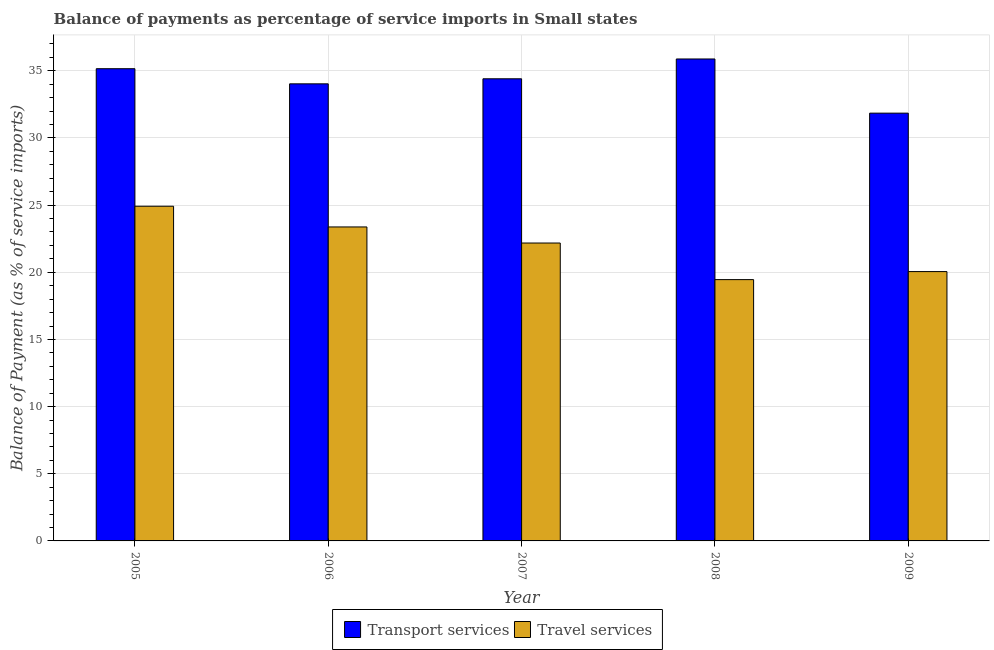How many different coloured bars are there?
Offer a terse response. 2. Are the number of bars per tick equal to the number of legend labels?
Make the answer very short. Yes. Are the number of bars on each tick of the X-axis equal?
Provide a short and direct response. Yes. What is the label of the 1st group of bars from the left?
Provide a succinct answer. 2005. In how many cases, is the number of bars for a given year not equal to the number of legend labels?
Provide a short and direct response. 0. What is the balance of payments of transport services in 2006?
Provide a succinct answer. 34.03. Across all years, what is the maximum balance of payments of transport services?
Make the answer very short. 35.88. Across all years, what is the minimum balance of payments of travel services?
Provide a succinct answer. 19.45. In which year was the balance of payments of transport services minimum?
Ensure brevity in your answer.  2009. What is the total balance of payments of travel services in the graph?
Your answer should be compact. 109.98. What is the difference between the balance of payments of travel services in 2007 and that in 2009?
Provide a succinct answer. 2.13. What is the difference between the balance of payments of transport services in 2008 and the balance of payments of travel services in 2009?
Provide a short and direct response. 4.03. What is the average balance of payments of transport services per year?
Your answer should be very brief. 34.26. What is the ratio of the balance of payments of travel services in 2005 to that in 2009?
Make the answer very short. 1.24. Is the balance of payments of travel services in 2006 less than that in 2007?
Offer a very short reply. No. Is the difference between the balance of payments of travel services in 2006 and 2007 greater than the difference between the balance of payments of transport services in 2006 and 2007?
Provide a succinct answer. No. What is the difference between the highest and the second highest balance of payments of travel services?
Keep it short and to the point. 1.54. What is the difference between the highest and the lowest balance of payments of transport services?
Offer a very short reply. 4.03. In how many years, is the balance of payments of travel services greater than the average balance of payments of travel services taken over all years?
Offer a very short reply. 3. Is the sum of the balance of payments of travel services in 2006 and 2009 greater than the maximum balance of payments of transport services across all years?
Provide a short and direct response. Yes. What does the 2nd bar from the left in 2005 represents?
Your response must be concise. Travel services. What does the 1st bar from the right in 2006 represents?
Offer a very short reply. Travel services. How many bars are there?
Your response must be concise. 10. How many years are there in the graph?
Provide a succinct answer. 5. Does the graph contain any zero values?
Give a very brief answer. No. How many legend labels are there?
Ensure brevity in your answer.  2. What is the title of the graph?
Ensure brevity in your answer.  Balance of payments as percentage of service imports in Small states. What is the label or title of the X-axis?
Your answer should be compact. Year. What is the label or title of the Y-axis?
Provide a short and direct response. Balance of Payment (as % of service imports). What is the Balance of Payment (as % of service imports) in Transport services in 2005?
Make the answer very short. 35.16. What is the Balance of Payment (as % of service imports) of Travel services in 2005?
Provide a succinct answer. 24.92. What is the Balance of Payment (as % of service imports) in Transport services in 2006?
Your answer should be very brief. 34.03. What is the Balance of Payment (as % of service imports) of Travel services in 2006?
Your response must be concise. 23.38. What is the Balance of Payment (as % of service imports) in Transport services in 2007?
Your answer should be compact. 34.41. What is the Balance of Payment (as % of service imports) in Travel services in 2007?
Provide a short and direct response. 22.18. What is the Balance of Payment (as % of service imports) of Transport services in 2008?
Offer a terse response. 35.88. What is the Balance of Payment (as % of service imports) in Travel services in 2008?
Provide a succinct answer. 19.45. What is the Balance of Payment (as % of service imports) of Transport services in 2009?
Your answer should be compact. 31.85. What is the Balance of Payment (as % of service imports) of Travel services in 2009?
Give a very brief answer. 20.05. Across all years, what is the maximum Balance of Payment (as % of service imports) in Transport services?
Offer a terse response. 35.88. Across all years, what is the maximum Balance of Payment (as % of service imports) in Travel services?
Provide a short and direct response. 24.92. Across all years, what is the minimum Balance of Payment (as % of service imports) of Transport services?
Make the answer very short. 31.85. Across all years, what is the minimum Balance of Payment (as % of service imports) in Travel services?
Give a very brief answer. 19.45. What is the total Balance of Payment (as % of service imports) of Transport services in the graph?
Give a very brief answer. 171.32. What is the total Balance of Payment (as % of service imports) in Travel services in the graph?
Your answer should be compact. 109.98. What is the difference between the Balance of Payment (as % of service imports) in Transport services in 2005 and that in 2006?
Offer a terse response. 1.13. What is the difference between the Balance of Payment (as % of service imports) of Travel services in 2005 and that in 2006?
Provide a short and direct response. 1.54. What is the difference between the Balance of Payment (as % of service imports) of Transport services in 2005 and that in 2007?
Your answer should be compact. 0.75. What is the difference between the Balance of Payment (as % of service imports) in Travel services in 2005 and that in 2007?
Your response must be concise. 2.74. What is the difference between the Balance of Payment (as % of service imports) of Transport services in 2005 and that in 2008?
Offer a terse response. -0.72. What is the difference between the Balance of Payment (as % of service imports) in Travel services in 2005 and that in 2008?
Make the answer very short. 5.46. What is the difference between the Balance of Payment (as % of service imports) of Transport services in 2005 and that in 2009?
Offer a very short reply. 3.31. What is the difference between the Balance of Payment (as % of service imports) of Travel services in 2005 and that in 2009?
Your answer should be very brief. 4.87. What is the difference between the Balance of Payment (as % of service imports) in Transport services in 2006 and that in 2007?
Your answer should be very brief. -0.38. What is the difference between the Balance of Payment (as % of service imports) of Travel services in 2006 and that in 2007?
Make the answer very short. 1.2. What is the difference between the Balance of Payment (as % of service imports) of Transport services in 2006 and that in 2008?
Your answer should be very brief. -1.85. What is the difference between the Balance of Payment (as % of service imports) of Travel services in 2006 and that in 2008?
Provide a succinct answer. 3.92. What is the difference between the Balance of Payment (as % of service imports) of Transport services in 2006 and that in 2009?
Provide a short and direct response. 2.18. What is the difference between the Balance of Payment (as % of service imports) of Travel services in 2006 and that in 2009?
Give a very brief answer. 3.32. What is the difference between the Balance of Payment (as % of service imports) in Transport services in 2007 and that in 2008?
Ensure brevity in your answer.  -1.48. What is the difference between the Balance of Payment (as % of service imports) of Travel services in 2007 and that in 2008?
Your answer should be very brief. 2.72. What is the difference between the Balance of Payment (as % of service imports) of Transport services in 2007 and that in 2009?
Make the answer very short. 2.56. What is the difference between the Balance of Payment (as % of service imports) in Travel services in 2007 and that in 2009?
Your answer should be compact. 2.13. What is the difference between the Balance of Payment (as % of service imports) in Transport services in 2008 and that in 2009?
Your answer should be very brief. 4.03. What is the difference between the Balance of Payment (as % of service imports) in Travel services in 2008 and that in 2009?
Your response must be concise. -0.6. What is the difference between the Balance of Payment (as % of service imports) of Transport services in 2005 and the Balance of Payment (as % of service imports) of Travel services in 2006?
Offer a terse response. 11.78. What is the difference between the Balance of Payment (as % of service imports) in Transport services in 2005 and the Balance of Payment (as % of service imports) in Travel services in 2007?
Provide a short and direct response. 12.98. What is the difference between the Balance of Payment (as % of service imports) of Transport services in 2005 and the Balance of Payment (as % of service imports) of Travel services in 2008?
Make the answer very short. 15.7. What is the difference between the Balance of Payment (as % of service imports) of Transport services in 2005 and the Balance of Payment (as % of service imports) of Travel services in 2009?
Give a very brief answer. 15.1. What is the difference between the Balance of Payment (as % of service imports) in Transport services in 2006 and the Balance of Payment (as % of service imports) in Travel services in 2007?
Provide a short and direct response. 11.85. What is the difference between the Balance of Payment (as % of service imports) in Transport services in 2006 and the Balance of Payment (as % of service imports) in Travel services in 2008?
Offer a very short reply. 14.58. What is the difference between the Balance of Payment (as % of service imports) of Transport services in 2006 and the Balance of Payment (as % of service imports) of Travel services in 2009?
Your response must be concise. 13.98. What is the difference between the Balance of Payment (as % of service imports) of Transport services in 2007 and the Balance of Payment (as % of service imports) of Travel services in 2008?
Offer a terse response. 14.95. What is the difference between the Balance of Payment (as % of service imports) of Transport services in 2007 and the Balance of Payment (as % of service imports) of Travel services in 2009?
Your response must be concise. 14.35. What is the difference between the Balance of Payment (as % of service imports) in Transport services in 2008 and the Balance of Payment (as % of service imports) in Travel services in 2009?
Provide a succinct answer. 15.83. What is the average Balance of Payment (as % of service imports) of Transport services per year?
Keep it short and to the point. 34.26. What is the average Balance of Payment (as % of service imports) in Travel services per year?
Your answer should be compact. 22. In the year 2005, what is the difference between the Balance of Payment (as % of service imports) in Transport services and Balance of Payment (as % of service imports) in Travel services?
Your answer should be compact. 10.24. In the year 2006, what is the difference between the Balance of Payment (as % of service imports) of Transport services and Balance of Payment (as % of service imports) of Travel services?
Provide a short and direct response. 10.65. In the year 2007, what is the difference between the Balance of Payment (as % of service imports) in Transport services and Balance of Payment (as % of service imports) in Travel services?
Make the answer very short. 12.23. In the year 2008, what is the difference between the Balance of Payment (as % of service imports) of Transport services and Balance of Payment (as % of service imports) of Travel services?
Offer a terse response. 16.43. In the year 2009, what is the difference between the Balance of Payment (as % of service imports) in Transport services and Balance of Payment (as % of service imports) in Travel services?
Make the answer very short. 11.8. What is the ratio of the Balance of Payment (as % of service imports) in Transport services in 2005 to that in 2006?
Make the answer very short. 1.03. What is the ratio of the Balance of Payment (as % of service imports) in Travel services in 2005 to that in 2006?
Make the answer very short. 1.07. What is the ratio of the Balance of Payment (as % of service imports) in Transport services in 2005 to that in 2007?
Provide a short and direct response. 1.02. What is the ratio of the Balance of Payment (as % of service imports) of Travel services in 2005 to that in 2007?
Give a very brief answer. 1.12. What is the ratio of the Balance of Payment (as % of service imports) in Transport services in 2005 to that in 2008?
Your answer should be very brief. 0.98. What is the ratio of the Balance of Payment (as % of service imports) of Travel services in 2005 to that in 2008?
Keep it short and to the point. 1.28. What is the ratio of the Balance of Payment (as % of service imports) in Transport services in 2005 to that in 2009?
Your answer should be very brief. 1.1. What is the ratio of the Balance of Payment (as % of service imports) in Travel services in 2005 to that in 2009?
Provide a succinct answer. 1.24. What is the ratio of the Balance of Payment (as % of service imports) in Travel services in 2006 to that in 2007?
Your answer should be compact. 1.05. What is the ratio of the Balance of Payment (as % of service imports) of Transport services in 2006 to that in 2008?
Your answer should be compact. 0.95. What is the ratio of the Balance of Payment (as % of service imports) of Travel services in 2006 to that in 2008?
Offer a very short reply. 1.2. What is the ratio of the Balance of Payment (as % of service imports) in Transport services in 2006 to that in 2009?
Provide a short and direct response. 1.07. What is the ratio of the Balance of Payment (as % of service imports) in Travel services in 2006 to that in 2009?
Keep it short and to the point. 1.17. What is the ratio of the Balance of Payment (as % of service imports) of Transport services in 2007 to that in 2008?
Keep it short and to the point. 0.96. What is the ratio of the Balance of Payment (as % of service imports) of Travel services in 2007 to that in 2008?
Ensure brevity in your answer.  1.14. What is the ratio of the Balance of Payment (as % of service imports) of Transport services in 2007 to that in 2009?
Your answer should be compact. 1.08. What is the ratio of the Balance of Payment (as % of service imports) of Travel services in 2007 to that in 2009?
Offer a terse response. 1.11. What is the ratio of the Balance of Payment (as % of service imports) of Transport services in 2008 to that in 2009?
Provide a succinct answer. 1.13. What is the ratio of the Balance of Payment (as % of service imports) of Travel services in 2008 to that in 2009?
Ensure brevity in your answer.  0.97. What is the difference between the highest and the second highest Balance of Payment (as % of service imports) in Transport services?
Provide a short and direct response. 0.72. What is the difference between the highest and the second highest Balance of Payment (as % of service imports) of Travel services?
Your answer should be very brief. 1.54. What is the difference between the highest and the lowest Balance of Payment (as % of service imports) in Transport services?
Your response must be concise. 4.03. What is the difference between the highest and the lowest Balance of Payment (as % of service imports) of Travel services?
Provide a short and direct response. 5.46. 